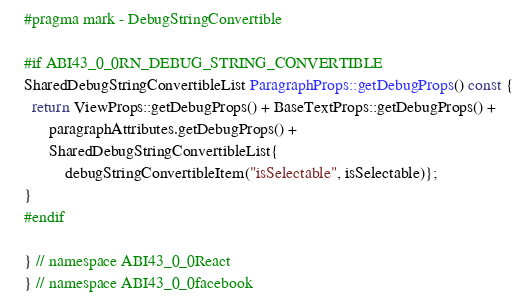<code> <loc_0><loc_0><loc_500><loc_500><_C++_>
#pragma mark - DebugStringConvertible

#if ABI43_0_0RN_DEBUG_STRING_CONVERTIBLE
SharedDebugStringConvertibleList ParagraphProps::getDebugProps() const {
  return ViewProps::getDebugProps() + BaseTextProps::getDebugProps() +
      paragraphAttributes.getDebugProps() +
      SharedDebugStringConvertibleList{
          debugStringConvertibleItem("isSelectable", isSelectable)};
}
#endif

} // namespace ABI43_0_0React
} // namespace ABI43_0_0facebook
</code> 